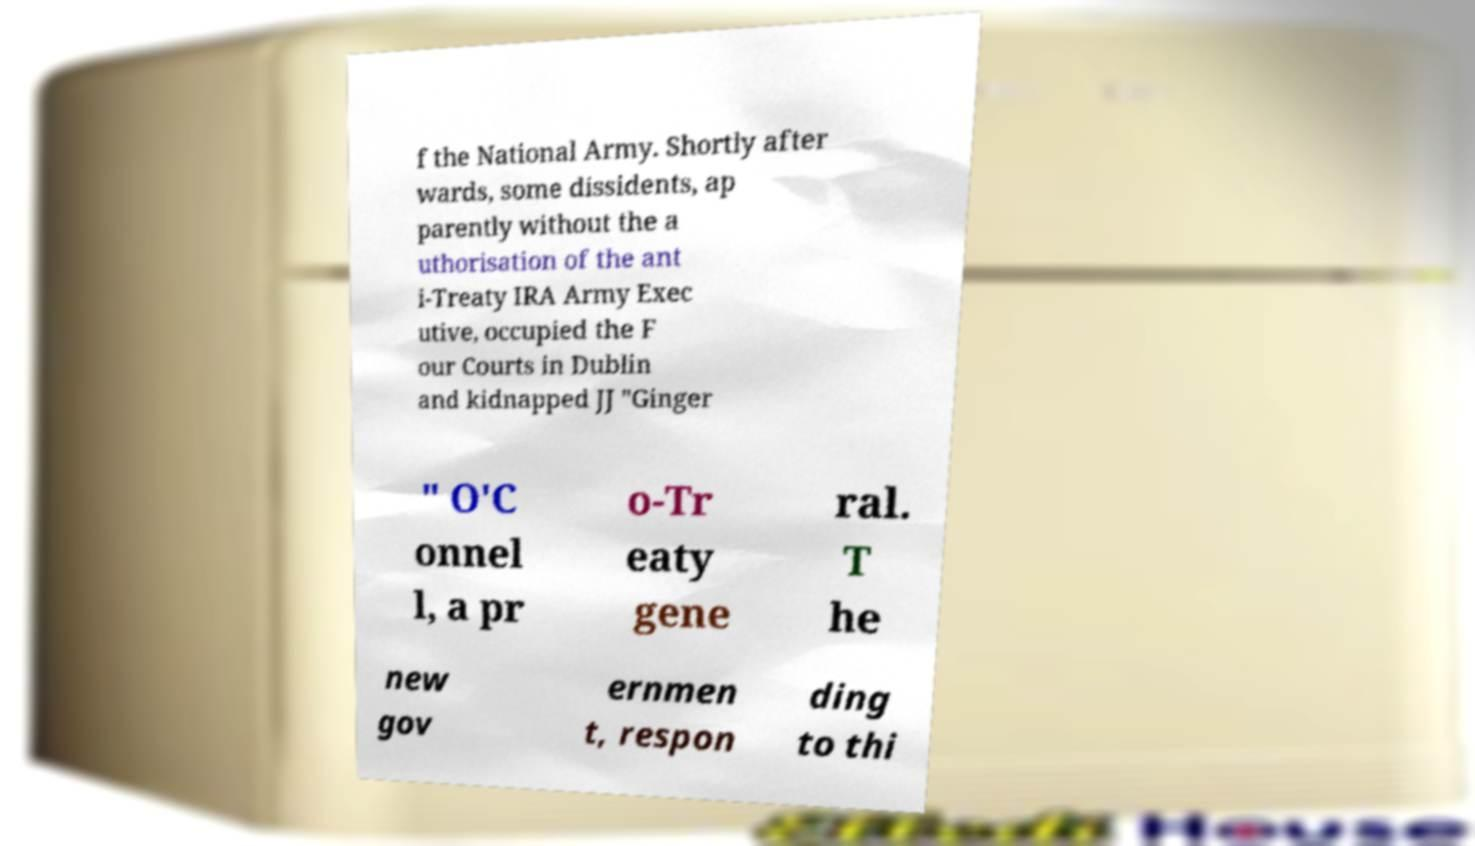There's text embedded in this image that I need extracted. Can you transcribe it verbatim? f the National Army. Shortly after wards, some dissidents, ap parently without the a uthorisation of the ant i-Treaty IRA Army Exec utive, occupied the F our Courts in Dublin and kidnapped JJ "Ginger " O'C onnel l, a pr o-Tr eaty gene ral. T he new gov ernmen t, respon ding to thi 